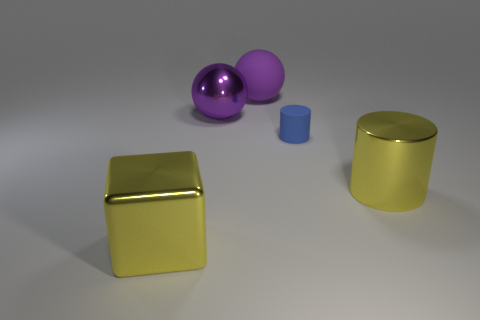There is a yellow thing that is the same shape as the blue rubber object; what is its material?
Provide a short and direct response. Metal. Is there anything else that is the same material as the yellow cube?
Offer a terse response. Yes. Are there the same number of yellow cubes on the right side of the yellow cylinder and tiny blue rubber cylinders that are in front of the yellow metal block?
Your answer should be compact. Yes. Do the tiny blue object and the large yellow cube have the same material?
Make the answer very short. No. What number of purple things are rubber cylinders or big cylinders?
Make the answer very short. 0. How many big yellow metallic things are the same shape as the large matte thing?
Offer a terse response. 0. What is the material of the cube?
Provide a succinct answer. Metal. Are there an equal number of large purple matte balls that are in front of the large shiny cylinder and tiny green metallic objects?
Keep it short and to the point. Yes. The purple metal thing that is the same size as the purple matte sphere is what shape?
Make the answer very short. Sphere. There is a big purple sphere that is in front of the large purple matte ball; is there a purple object that is left of it?
Provide a succinct answer. No. 